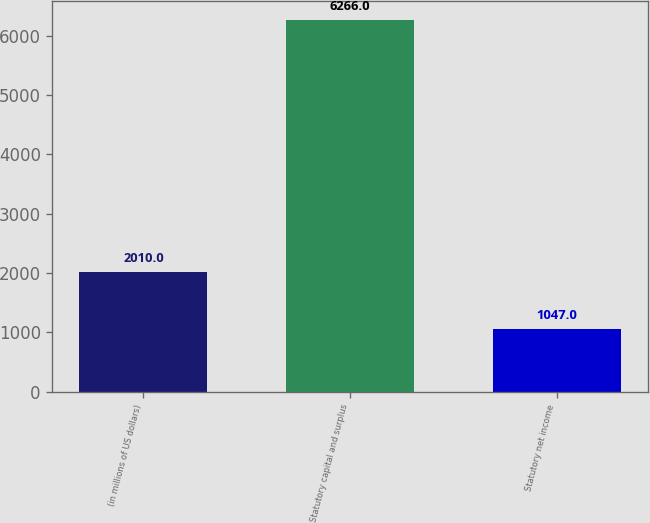Convert chart to OTSL. <chart><loc_0><loc_0><loc_500><loc_500><bar_chart><fcel>(in millions of US dollars)<fcel>Statutory capital and surplus<fcel>Statutory net income<nl><fcel>2010<fcel>6266<fcel>1047<nl></chart> 